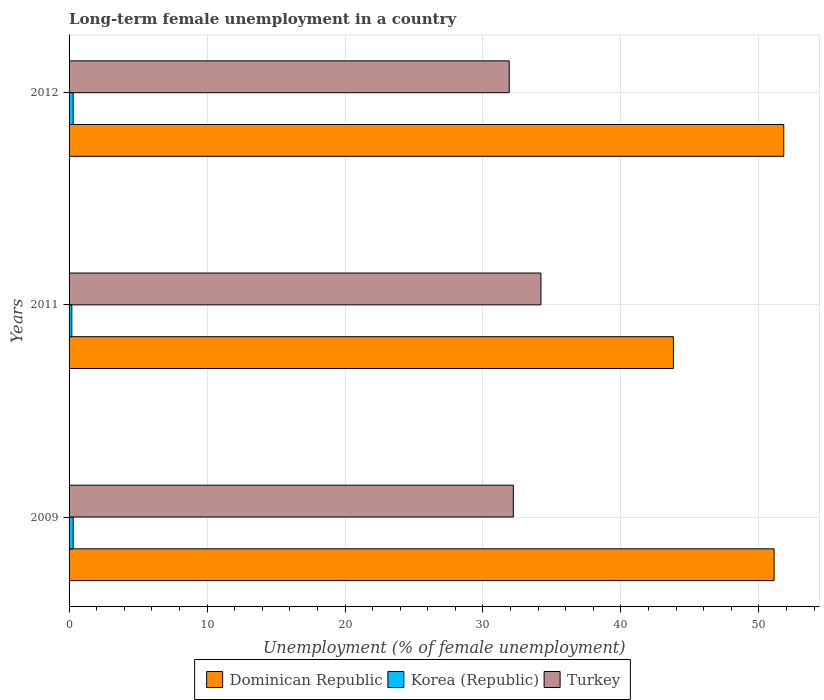How many different coloured bars are there?
Offer a terse response. 3. Are the number of bars on each tick of the Y-axis equal?
Your answer should be compact. Yes. How many bars are there on the 2nd tick from the bottom?
Give a very brief answer. 3. What is the label of the 1st group of bars from the top?
Offer a very short reply. 2012. In how many cases, is the number of bars for a given year not equal to the number of legend labels?
Your answer should be compact. 0. What is the percentage of long-term unemployed female population in Dominican Republic in 2009?
Offer a very short reply. 51.1. Across all years, what is the maximum percentage of long-term unemployed female population in Turkey?
Your answer should be compact. 34.2. Across all years, what is the minimum percentage of long-term unemployed female population in Korea (Republic)?
Your answer should be compact. 0.2. In which year was the percentage of long-term unemployed female population in Turkey minimum?
Your response must be concise. 2012. What is the total percentage of long-term unemployed female population in Dominican Republic in the graph?
Give a very brief answer. 146.7. What is the difference between the percentage of long-term unemployed female population in Dominican Republic in 2009 and the percentage of long-term unemployed female population in Korea (Republic) in 2012?
Keep it short and to the point. 50.8. What is the average percentage of long-term unemployed female population in Turkey per year?
Offer a terse response. 32.77. In the year 2009, what is the difference between the percentage of long-term unemployed female population in Dominican Republic and percentage of long-term unemployed female population in Korea (Republic)?
Keep it short and to the point. 50.8. In how many years, is the percentage of long-term unemployed female population in Turkey greater than 40 %?
Your response must be concise. 0. What is the ratio of the percentage of long-term unemployed female population in Korea (Republic) in 2009 to that in 2011?
Ensure brevity in your answer.  1.5. What does the 1st bar from the bottom in 2012 represents?
Offer a terse response. Dominican Republic. Is it the case that in every year, the sum of the percentage of long-term unemployed female population in Turkey and percentage of long-term unemployed female population in Korea (Republic) is greater than the percentage of long-term unemployed female population in Dominican Republic?
Offer a terse response. No. Are all the bars in the graph horizontal?
Your answer should be very brief. Yes. How many years are there in the graph?
Offer a very short reply. 3. Does the graph contain any zero values?
Your response must be concise. No. Does the graph contain grids?
Provide a succinct answer. Yes. Where does the legend appear in the graph?
Ensure brevity in your answer.  Bottom center. How many legend labels are there?
Offer a terse response. 3. What is the title of the graph?
Your answer should be compact. Long-term female unemployment in a country. Does "Caribbean small states" appear as one of the legend labels in the graph?
Your answer should be compact. No. What is the label or title of the X-axis?
Your response must be concise. Unemployment (% of female unemployment). What is the label or title of the Y-axis?
Offer a very short reply. Years. What is the Unemployment (% of female unemployment) in Dominican Republic in 2009?
Offer a terse response. 51.1. What is the Unemployment (% of female unemployment) of Korea (Republic) in 2009?
Make the answer very short. 0.3. What is the Unemployment (% of female unemployment) of Turkey in 2009?
Your answer should be compact. 32.2. What is the Unemployment (% of female unemployment) in Dominican Republic in 2011?
Your response must be concise. 43.8. What is the Unemployment (% of female unemployment) of Korea (Republic) in 2011?
Your response must be concise. 0.2. What is the Unemployment (% of female unemployment) in Turkey in 2011?
Keep it short and to the point. 34.2. What is the Unemployment (% of female unemployment) in Dominican Republic in 2012?
Offer a very short reply. 51.8. What is the Unemployment (% of female unemployment) in Korea (Republic) in 2012?
Provide a succinct answer. 0.3. What is the Unemployment (% of female unemployment) in Turkey in 2012?
Keep it short and to the point. 31.9. Across all years, what is the maximum Unemployment (% of female unemployment) of Dominican Republic?
Your answer should be very brief. 51.8. Across all years, what is the maximum Unemployment (% of female unemployment) in Korea (Republic)?
Offer a very short reply. 0.3. Across all years, what is the maximum Unemployment (% of female unemployment) in Turkey?
Make the answer very short. 34.2. Across all years, what is the minimum Unemployment (% of female unemployment) in Dominican Republic?
Keep it short and to the point. 43.8. Across all years, what is the minimum Unemployment (% of female unemployment) of Korea (Republic)?
Provide a succinct answer. 0.2. Across all years, what is the minimum Unemployment (% of female unemployment) in Turkey?
Your answer should be very brief. 31.9. What is the total Unemployment (% of female unemployment) in Dominican Republic in the graph?
Ensure brevity in your answer.  146.7. What is the total Unemployment (% of female unemployment) of Korea (Republic) in the graph?
Ensure brevity in your answer.  0.8. What is the total Unemployment (% of female unemployment) of Turkey in the graph?
Your answer should be very brief. 98.3. What is the difference between the Unemployment (% of female unemployment) in Korea (Republic) in 2009 and that in 2011?
Your answer should be compact. 0.1. What is the difference between the Unemployment (% of female unemployment) in Turkey in 2009 and that in 2012?
Ensure brevity in your answer.  0.3. What is the difference between the Unemployment (% of female unemployment) of Korea (Republic) in 2011 and that in 2012?
Make the answer very short. -0.1. What is the difference between the Unemployment (% of female unemployment) of Turkey in 2011 and that in 2012?
Keep it short and to the point. 2.3. What is the difference between the Unemployment (% of female unemployment) in Dominican Republic in 2009 and the Unemployment (% of female unemployment) in Korea (Republic) in 2011?
Provide a short and direct response. 50.9. What is the difference between the Unemployment (% of female unemployment) of Dominican Republic in 2009 and the Unemployment (% of female unemployment) of Turkey in 2011?
Ensure brevity in your answer.  16.9. What is the difference between the Unemployment (% of female unemployment) in Korea (Republic) in 2009 and the Unemployment (% of female unemployment) in Turkey in 2011?
Your answer should be compact. -33.9. What is the difference between the Unemployment (% of female unemployment) in Dominican Republic in 2009 and the Unemployment (% of female unemployment) in Korea (Republic) in 2012?
Your answer should be compact. 50.8. What is the difference between the Unemployment (% of female unemployment) of Dominican Republic in 2009 and the Unemployment (% of female unemployment) of Turkey in 2012?
Your answer should be compact. 19.2. What is the difference between the Unemployment (% of female unemployment) in Korea (Republic) in 2009 and the Unemployment (% of female unemployment) in Turkey in 2012?
Your response must be concise. -31.6. What is the difference between the Unemployment (% of female unemployment) in Dominican Republic in 2011 and the Unemployment (% of female unemployment) in Korea (Republic) in 2012?
Offer a very short reply. 43.5. What is the difference between the Unemployment (% of female unemployment) in Korea (Republic) in 2011 and the Unemployment (% of female unemployment) in Turkey in 2012?
Offer a very short reply. -31.7. What is the average Unemployment (% of female unemployment) of Dominican Republic per year?
Ensure brevity in your answer.  48.9. What is the average Unemployment (% of female unemployment) of Korea (Republic) per year?
Keep it short and to the point. 0.27. What is the average Unemployment (% of female unemployment) of Turkey per year?
Provide a succinct answer. 32.77. In the year 2009, what is the difference between the Unemployment (% of female unemployment) of Dominican Republic and Unemployment (% of female unemployment) of Korea (Republic)?
Provide a succinct answer. 50.8. In the year 2009, what is the difference between the Unemployment (% of female unemployment) in Korea (Republic) and Unemployment (% of female unemployment) in Turkey?
Provide a succinct answer. -31.9. In the year 2011, what is the difference between the Unemployment (% of female unemployment) of Dominican Republic and Unemployment (% of female unemployment) of Korea (Republic)?
Offer a very short reply. 43.6. In the year 2011, what is the difference between the Unemployment (% of female unemployment) of Dominican Republic and Unemployment (% of female unemployment) of Turkey?
Provide a short and direct response. 9.6. In the year 2011, what is the difference between the Unemployment (% of female unemployment) of Korea (Republic) and Unemployment (% of female unemployment) of Turkey?
Offer a very short reply. -34. In the year 2012, what is the difference between the Unemployment (% of female unemployment) in Dominican Republic and Unemployment (% of female unemployment) in Korea (Republic)?
Offer a very short reply. 51.5. In the year 2012, what is the difference between the Unemployment (% of female unemployment) in Dominican Republic and Unemployment (% of female unemployment) in Turkey?
Make the answer very short. 19.9. In the year 2012, what is the difference between the Unemployment (% of female unemployment) of Korea (Republic) and Unemployment (% of female unemployment) of Turkey?
Offer a terse response. -31.6. What is the ratio of the Unemployment (% of female unemployment) of Dominican Republic in 2009 to that in 2011?
Ensure brevity in your answer.  1.17. What is the ratio of the Unemployment (% of female unemployment) in Korea (Republic) in 2009 to that in 2011?
Offer a very short reply. 1.5. What is the ratio of the Unemployment (% of female unemployment) in Turkey in 2009 to that in 2011?
Offer a terse response. 0.94. What is the ratio of the Unemployment (% of female unemployment) of Dominican Republic in 2009 to that in 2012?
Keep it short and to the point. 0.99. What is the ratio of the Unemployment (% of female unemployment) in Turkey in 2009 to that in 2012?
Your answer should be compact. 1.01. What is the ratio of the Unemployment (% of female unemployment) in Dominican Republic in 2011 to that in 2012?
Keep it short and to the point. 0.85. What is the ratio of the Unemployment (% of female unemployment) of Korea (Republic) in 2011 to that in 2012?
Your answer should be compact. 0.67. What is the ratio of the Unemployment (% of female unemployment) in Turkey in 2011 to that in 2012?
Ensure brevity in your answer.  1.07. What is the difference between the highest and the second highest Unemployment (% of female unemployment) in Dominican Republic?
Give a very brief answer. 0.7. What is the difference between the highest and the second highest Unemployment (% of female unemployment) of Korea (Republic)?
Your answer should be very brief. 0. 